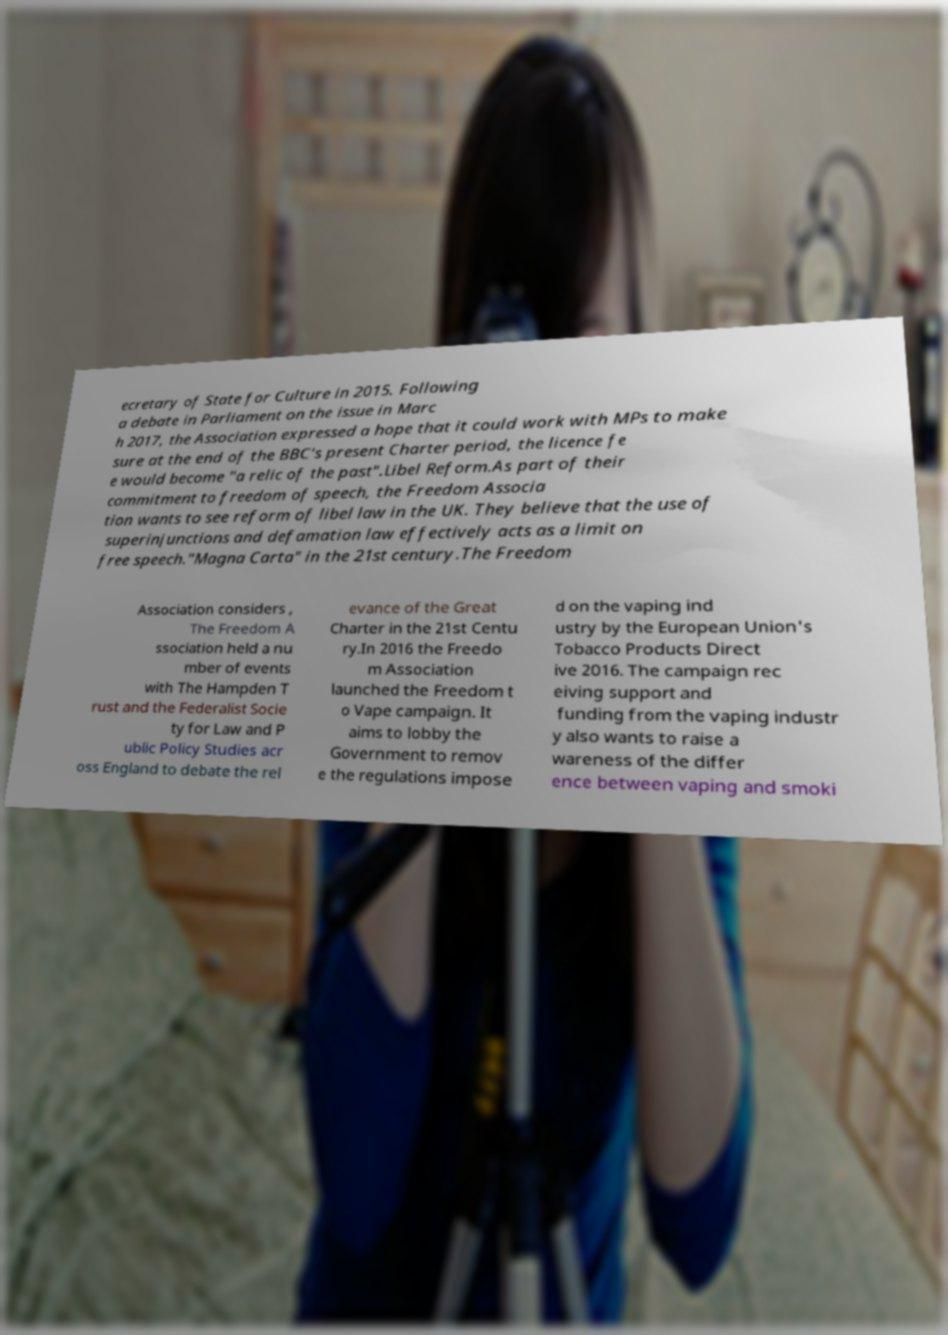Can you read and provide the text displayed in the image?This photo seems to have some interesting text. Can you extract and type it out for me? ecretary of State for Culture in 2015. Following a debate in Parliament on the issue in Marc h 2017, the Association expressed a hope that it could work with MPs to make sure at the end of the BBC's present Charter period, the licence fe e would become "a relic of the past".Libel Reform.As part of their commitment to freedom of speech, the Freedom Associa tion wants to see reform of libel law in the UK. They believe that the use of superinjunctions and defamation law effectively acts as a limit on free speech."Magna Carta" in the 21st century.The Freedom Association considers , The Freedom A ssociation held a nu mber of events with The Hampden T rust and the Federalist Socie ty for Law and P ublic Policy Studies acr oss England to debate the rel evance of the Great Charter in the 21st Centu ry.In 2016 the Freedo m Association launched the Freedom t o Vape campaign. It aims to lobby the Government to remov e the regulations impose d on the vaping ind ustry by the European Union's Tobacco Products Direct ive 2016. The campaign rec eiving support and funding from the vaping industr y also wants to raise a wareness of the differ ence between vaping and smoki 